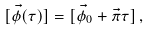Convert formula to latex. <formula><loc_0><loc_0><loc_500><loc_500>[ \vec { \phi } ( \tau ) ] = [ \vec { \phi } _ { 0 } + \vec { \pi } \tau ] \, ,</formula> 